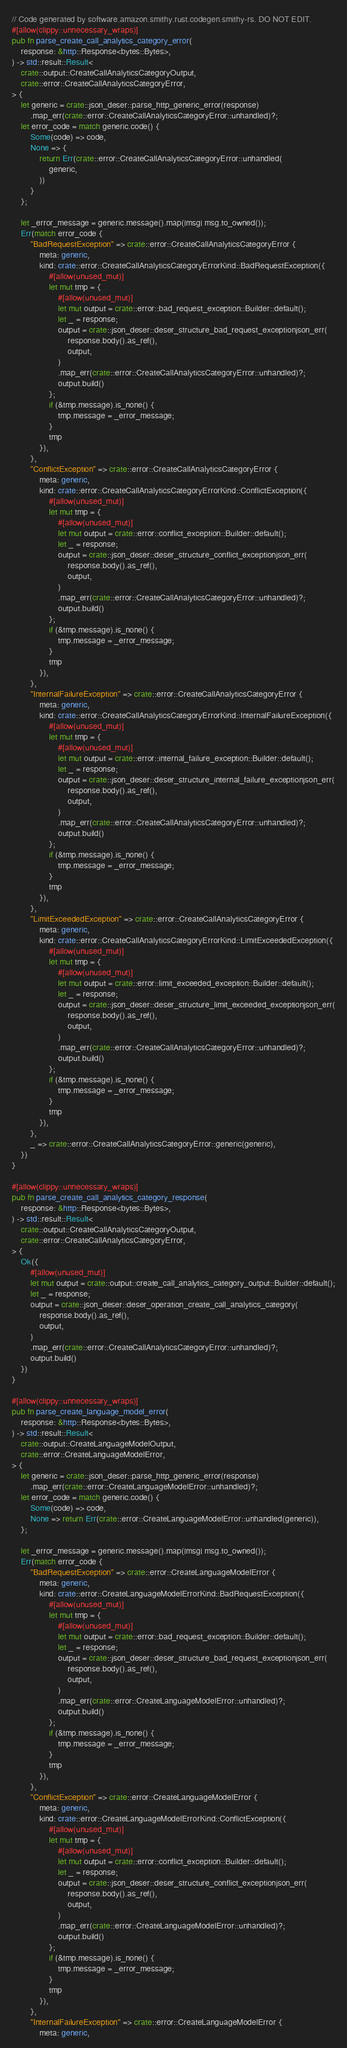<code> <loc_0><loc_0><loc_500><loc_500><_Rust_>// Code generated by software.amazon.smithy.rust.codegen.smithy-rs. DO NOT EDIT.
#[allow(clippy::unnecessary_wraps)]
pub fn parse_create_call_analytics_category_error(
    response: &http::Response<bytes::Bytes>,
) -> std::result::Result<
    crate::output::CreateCallAnalyticsCategoryOutput,
    crate::error::CreateCallAnalyticsCategoryError,
> {
    let generic = crate::json_deser::parse_http_generic_error(response)
        .map_err(crate::error::CreateCallAnalyticsCategoryError::unhandled)?;
    let error_code = match generic.code() {
        Some(code) => code,
        None => {
            return Err(crate::error::CreateCallAnalyticsCategoryError::unhandled(
                generic,
            ))
        }
    };

    let _error_message = generic.message().map(|msg| msg.to_owned());
    Err(match error_code {
        "BadRequestException" => crate::error::CreateCallAnalyticsCategoryError {
            meta: generic,
            kind: crate::error::CreateCallAnalyticsCategoryErrorKind::BadRequestException({
                #[allow(unused_mut)]
                let mut tmp = {
                    #[allow(unused_mut)]
                    let mut output = crate::error::bad_request_exception::Builder::default();
                    let _ = response;
                    output = crate::json_deser::deser_structure_bad_request_exceptionjson_err(
                        response.body().as_ref(),
                        output,
                    )
                    .map_err(crate::error::CreateCallAnalyticsCategoryError::unhandled)?;
                    output.build()
                };
                if (&tmp.message).is_none() {
                    tmp.message = _error_message;
                }
                tmp
            }),
        },
        "ConflictException" => crate::error::CreateCallAnalyticsCategoryError {
            meta: generic,
            kind: crate::error::CreateCallAnalyticsCategoryErrorKind::ConflictException({
                #[allow(unused_mut)]
                let mut tmp = {
                    #[allow(unused_mut)]
                    let mut output = crate::error::conflict_exception::Builder::default();
                    let _ = response;
                    output = crate::json_deser::deser_structure_conflict_exceptionjson_err(
                        response.body().as_ref(),
                        output,
                    )
                    .map_err(crate::error::CreateCallAnalyticsCategoryError::unhandled)?;
                    output.build()
                };
                if (&tmp.message).is_none() {
                    tmp.message = _error_message;
                }
                tmp
            }),
        },
        "InternalFailureException" => crate::error::CreateCallAnalyticsCategoryError {
            meta: generic,
            kind: crate::error::CreateCallAnalyticsCategoryErrorKind::InternalFailureException({
                #[allow(unused_mut)]
                let mut tmp = {
                    #[allow(unused_mut)]
                    let mut output = crate::error::internal_failure_exception::Builder::default();
                    let _ = response;
                    output = crate::json_deser::deser_structure_internal_failure_exceptionjson_err(
                        response.body().as_ref(),
                        output,
                    )
                    .map_err(crate::error::CreateCallAnalyticsCategoryError::unhandled)?;
                    output.build()
                };
                if (&tmp.message).is_none() {
                    tmp.message = _error_message;
                }
                tmp
            }),
        },
        "LimitExceededException" => crate::error::CreateCallAnalyticsCategoryError {
            meta: generic,
            kind: crate::error::CreateCallAnalyticsCategoryErrorKind::LimitExceededException({
                #[allow(unused_mut)]
                let mut tmp = {
                    #[allow(unused_mut)]
                    let mut output = crate::error::limit_exceeded_exception::Builder::default();
                    let _ = response;
                    output = crate::json_deser::deser_structure_limit_exceeded_exceptionjson_err(
                        response.body().as_ref(),
                        output,
                    )
                    .map_err(crate::error::CreateCallAnalyticsCategoryError::unhandled)?;
                    output.build()
                };
                if (&tmp.message).is_none() {
                    tmp.message = _error_message;
                }
                tmp
            }),
        },
        _ => crate::error::CreateCallAnalyticsCategoryError::generic(generic),
    })
}

#[allow(clippy::unnecessary_wraps)]
pub fn parse_create_call_analytics_category_response(
    response: &http::Response<bytes::Bytes>,
) -> std::result::Result<
    crate::output::CreateCallAnalyticsCategoryOutput,
    crate::error::CreateCallAnalyticsCategoryError,
> {
    Ok({
        #[allow(unused_mut)]
        let mut output = crate::output::create_call_analytics_category_output::Builder::default();
        let _ = response;
        output = crate::json_deser::deser_operation_create_call_analytics_category(
            response.body().as_ref(),
            output,
        )
        .map_err(crate::error::CreateCallAnalyticsCategoryError::unhandled)?;
        output.build()
    })
}

#[allow(clippy::unnecessary_wraps)]
pub fn parse_create_language_model_error(
    response: &http::Response<bytes::Bytes>,
) -> std::result::Result<
    crate::output::CreateLanguageModelOutput,
    crate::error::CreateLanguageModelError,
> {
    let generic = crate::json_deser::parse_http_generic_error(response)
        .map_err(crate::error::CreateLanguageModelError::unhandled)?;
    let error_code = match generic.code() {
        Some(code) => code,
        None => return Err(crate::error::CreateLanguageModelError::unhandled(generic)),
    };

    let _error_message = generic.message().map(|msg| msg.to_owned());
    Err(match error_code {
        "BadRequestException" => crate::error::CreateLanguageModelError {
            meta: generic,
            kind: crate::error::CreateLanguageModelErrorKind::BadRequestException({
                #[allow(unused_mut)]
                let mut tmp = {
                    #[allow(unused_mut)]
                    let mut output = crate::error::bad_request_exception::Builder::default();
                    let _ = response;
                    output = crate::json_deser::deser_structure_bad_request_exceptionjson_err(
                        response.body().as_ref(),
                        output,
                    )
                    .map_err(crate::error::CreateLanguageModelError::unhandled)?;
                    output.build()
                };
                if (&tmp.message).is_none() {
                    tmp.message = _error_message;
                }
                tmp
            }),
        },
        "ConflictException" => crate::error::CreateLanguageModelError {
            meta: generic,
            kind: crate::error::CreateLanguageModelErrorKind::ConflictException({
                #[allow(unused_mut)]
                let mut tmp = {
                    #[allow(unused_mut)]
                    let mut output = crate::error::conflict_exception::Builder::default();
                    let _ = response;
                    output = crate::json_deser::deser_structure_conflict_exceptionjson_err(
                        response.body().as_ref(),
                        output,
                    )
                    .map_err(crate::error::CreateLanguageModelError::unhandled)?;
                    output.build()
                };
                if (&tmp.message).is_none() {
                    tmp.message = _error_message;
                }
                tmp
            }),
        },
        "InternalFailureException" => crate::error::CreateLanguageModelError {
            meta: generic,</code> 